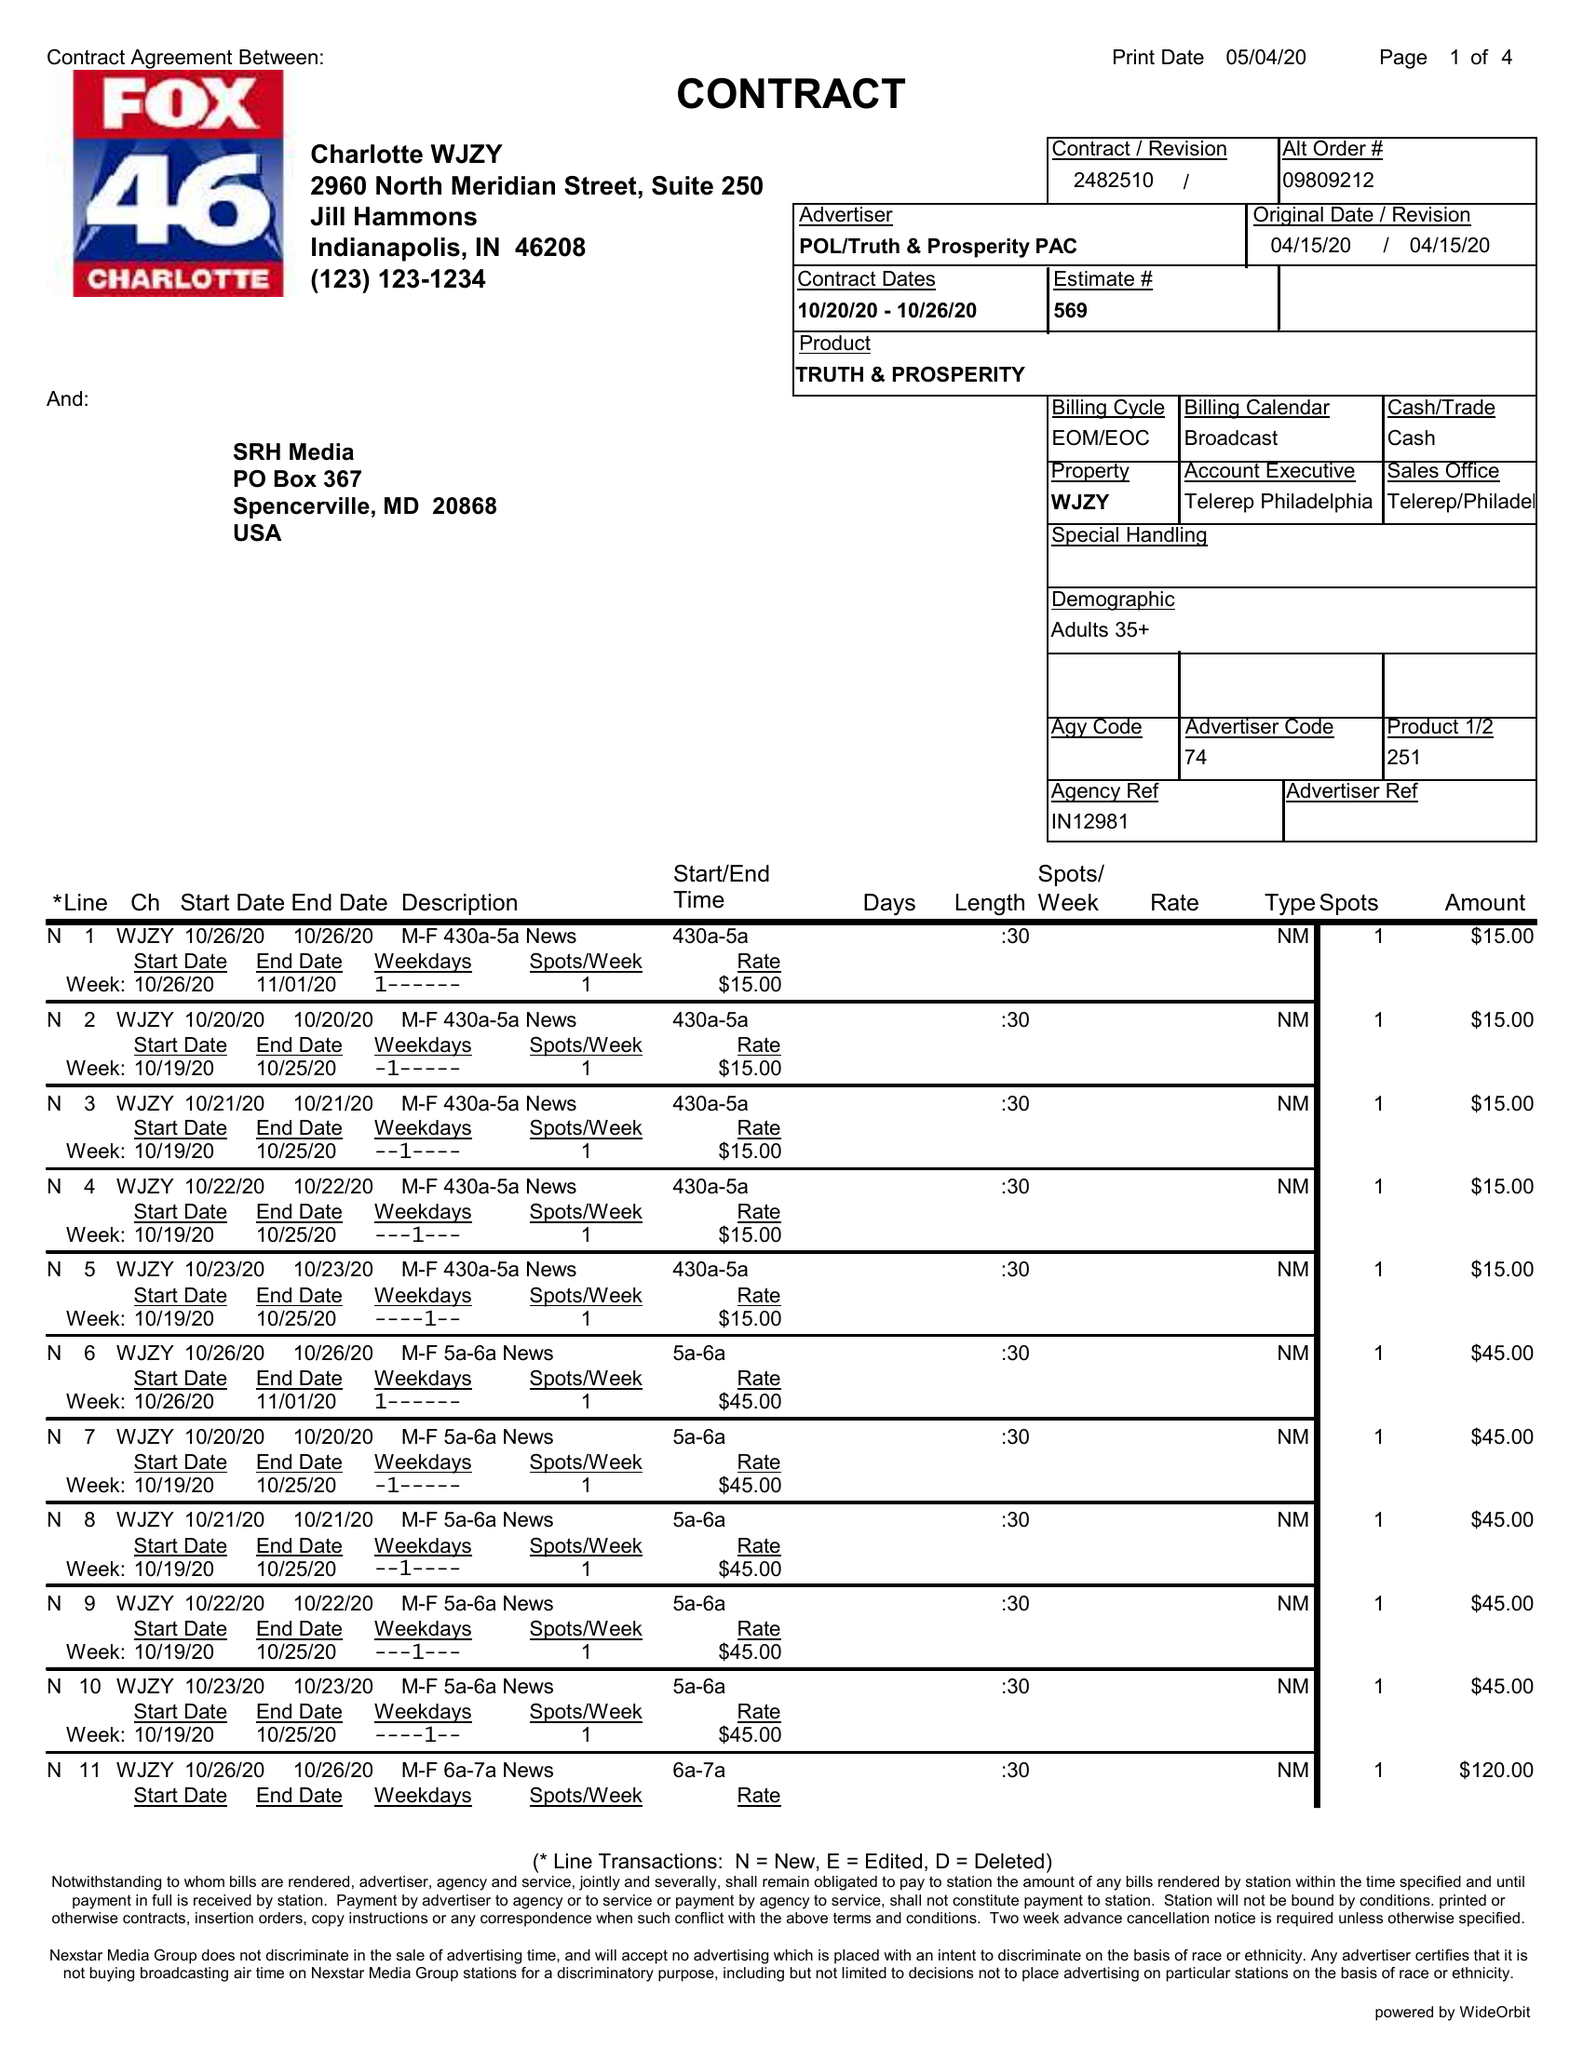What is the value for the advertiser?
Answer the question using a single word or phrase. POL/TRUTH&PROSPERITYPAC 